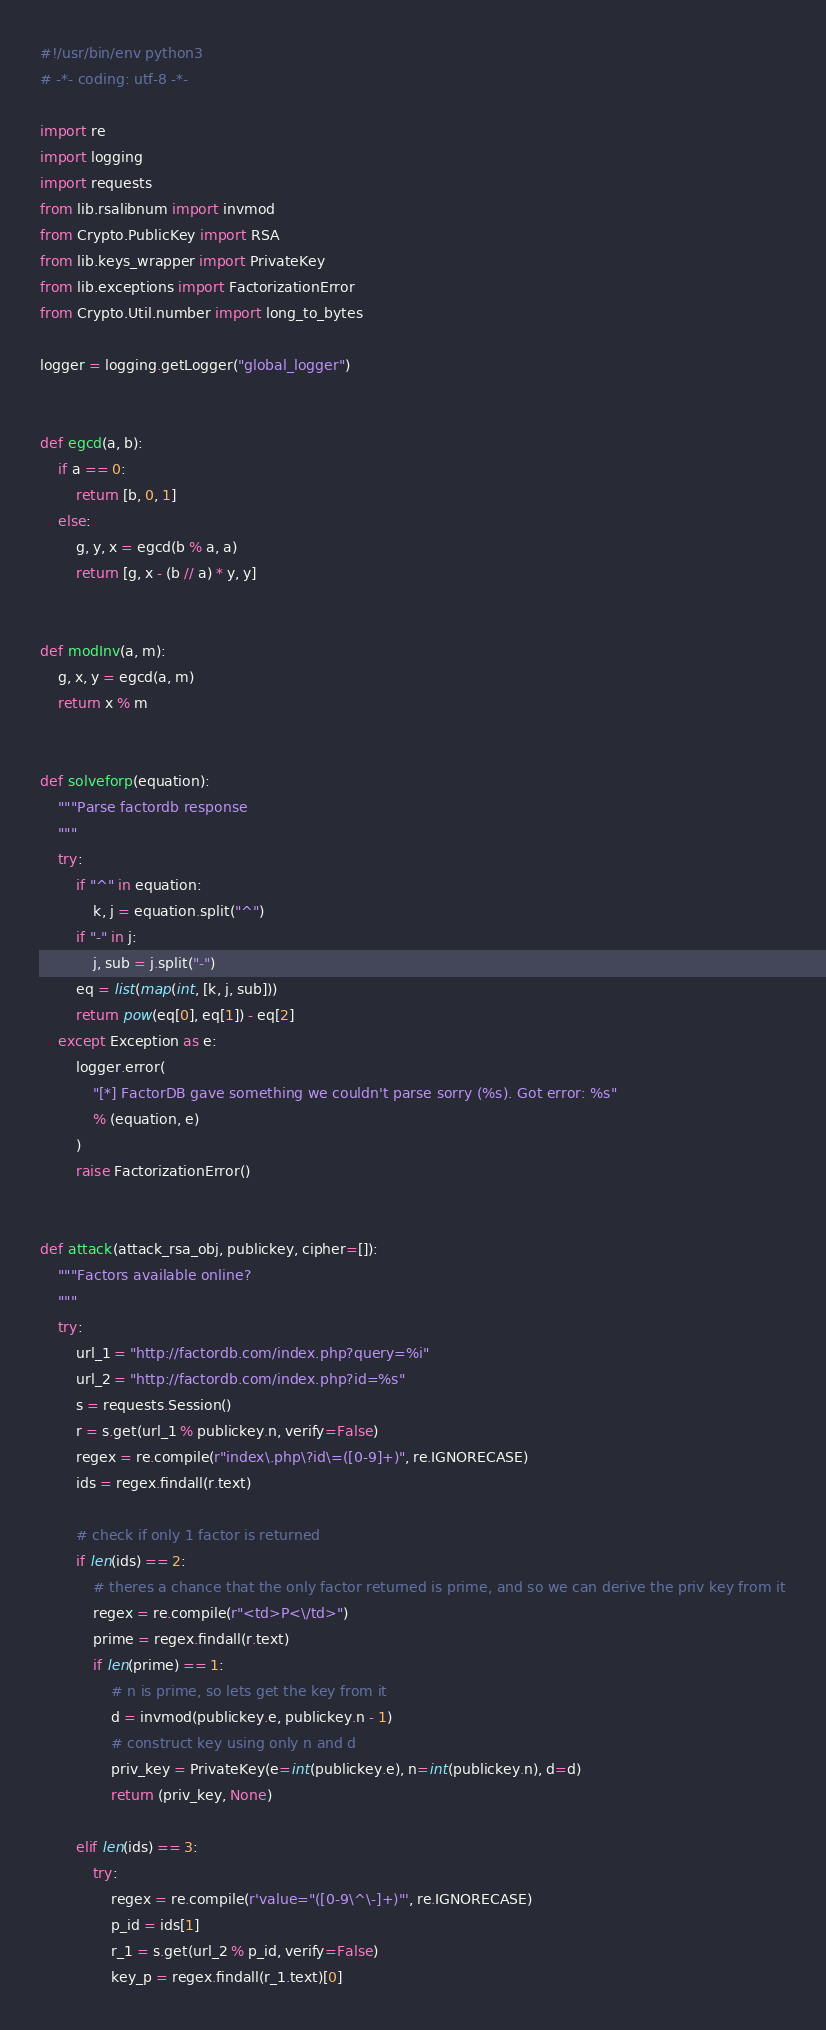<code> <loc_0><loc_0><loc_500><loc_500><_Python_>#!/usr/bin/env python3
# -*- coding: utf-8 -*-

import re
import logging
import requests
from lib.rsalibnum import invmod
from Crypto.PublicKey import RSA
from lib.keys_wrapper import PrivateKey
from lib.exceptions import FactorizationError
from Crypto.Util.number import long_to_bytes

logger = logging.getLogger("global_logger")


def egcd(a, b):
    if a == 0:
        return [b, 0, 1]
    else:
        g, y, x = egcd(b % a, a)
        return [g, x - (b // a) * y, y]


def modInv(a, m):
    g, x, y = egcd(a, m)
    return x % m


def solveforp(equation):
    """Parse factordb response
    """
    try:
        if "^" in equation:
            k, j = equation.split("^")
        if "-" in j:
            j, sub = j.split("-")
        eq = list(map(int, [k, j, sub]))
        return pow(eq[0], eq[1]) - eq[2]
    except Exception as e:
        logger.error(
            "[*] FactorDB gave something we couldn't parse sorry (%s). Got error: %s"
            % (equation, e)
        )
        raise FactorizationError()


def attack(attack_rsa_obj, publickey, cipher=[]):
    """Factors available online?
    """
    try:
        url_1 = "http://factordb.com/index.php?query=%i"
        url_2 = "http://factordb.com/index.php?id=%s"
        s = requests.Session()
        r = s.get(url_1 % publickey.n, verify=False)
        regex = re.compile(r"index\.php\?id\=([0-9]+)", re.IGNORECASE)
        ids = regex.findall(r.text)

        # check if only 1 factor is returned
        if len(ids) == 2:
            # theres a chance that the only factor returned is prime, and so we can derive the priv key from it
            regex = re.compile(r"<td>P<\/td>")
            prime = regex.findall(r.text)
            if len(prime) == 1:
                # n is prime, so lets get the key from it
                d = invmod(publickey.e, publickey.n - 1)
                # construct key using only n and d
                priv_key = PrivateKey(e=int(publickey.e), n=int(publickey.n), d=d)
                return (priv_key, None)

        elif len(ids) == 3:
            try:
                regex = re.compile(r'value="([0-9\^\-]+)"', re.IGNORECASE)
                p_id = ids[1]
                r_1 = s.get(url_2 % p_id, verify=False)
                key_p = regex.findall(r_1.text)[0]</code> 